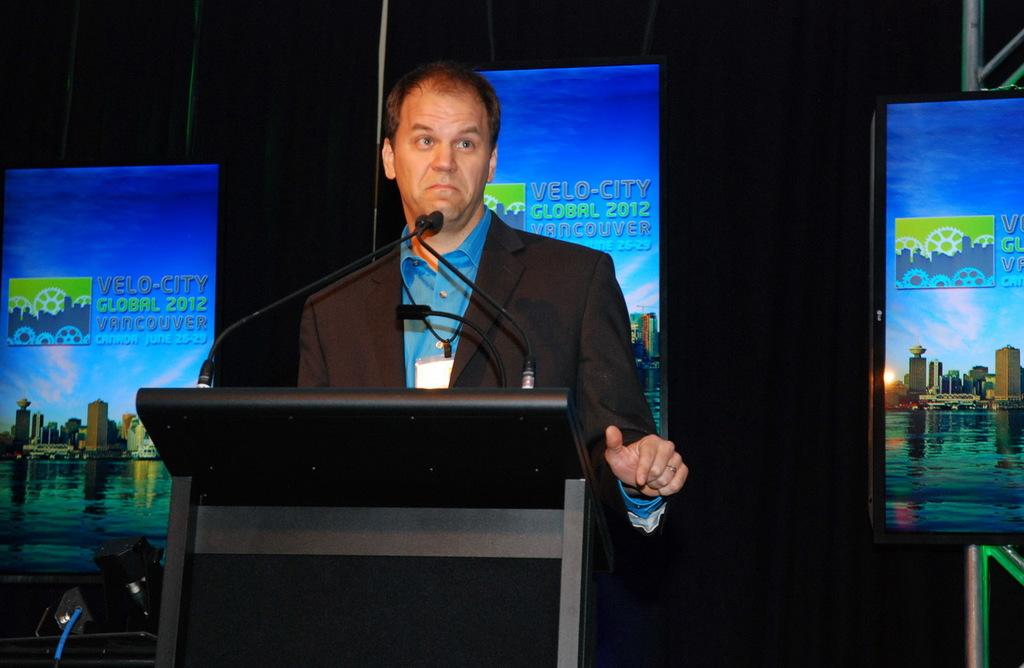What year is this presentation in?
Your answer should be very brief. 2012. Where was this presentation held at?
Your response must be concise. Vancouver. 